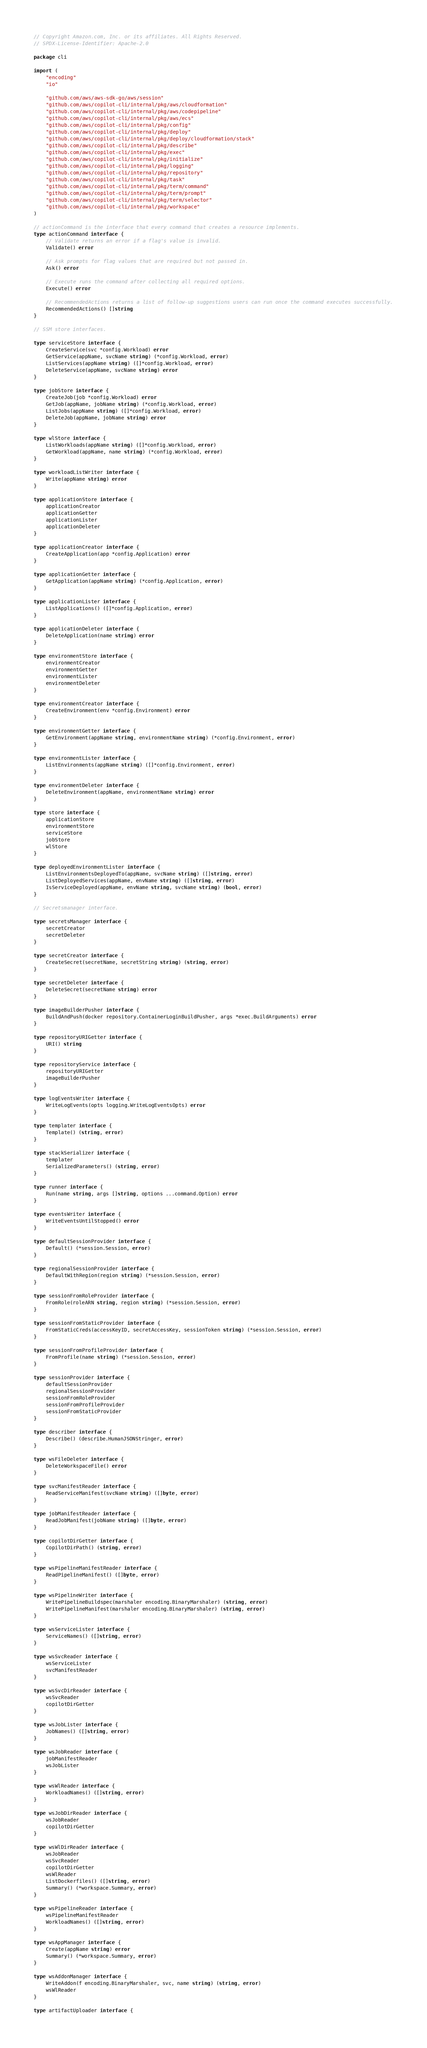<code> <loc_0><loc_0><loc_500><loc_500><_Go_>// Copyright Amazon.com, Inc. or its affiliates. All Rights Reserved.
// SPDX-License-Identifier: Apache-2.0

package cli

import (
	"encoding"
	"io"

	"github.com/aws/aws-sdk-go/aws/session"
	"github.com/aws/copilot-cli/internal/pkg/aws/cloudformation"
	"github.com/aws/copilot-cli/internal/pkg/aws/codepipeline"
	"github.com/aws/copilot-cli/internal/pkg/aws/ecs"
	"github.com/aws/copilot-cli/internal/pkg/config"
	"github.com/aws/copilot-cli/internal/pkg/deploy"
	"github.com/aws/copilot-cli/internal/pkg/deploy/cloudformation/stack"
	"github.com/aws/copilot-cli/internal/pkg/describe"
	"github.com/aws/copilot-cli/internal/pkg/exec"
	"github.com/aws/copilot-cli/internal/pkg/initialize"
	"github.com/aws/copilot-cli/internal/pkg/logging"
	"github.com/aws/copilot-cli/internal/pkg/repository"
	"github.com/aws/copilot-cli/internal/pkg/task"
	"github.com/aws/copilot-cli/internal/pkg/term/command"
	"github.com/aws/copilot-cli/internal/pkg/term/prompt"
	"github.com/aws/copilot-cli/internal/pkg/term/selector"
	"github.com/aws/copilot-cli/internal/pkg/workspace"
)

// actionCommand is the interface that every command that creates a resource implements.
type actionCommand interface {
	// Validate returns an error if a flag's value is invalid.
	Validate() error

	// Ask prompts for flag values that are required but not passed in.
	Ask() error

	// Execute runs the command after collecting all required options.
	Execute() error

	// RecommendedActions returns a list of follow-up suggestions users can run once the command executes successfully.
	RecommendedActions() []string
}

// SSM store interfaces.

type serviceStore interface {
	CreateService(svc *config.Workload) error
	GetService(appName, svcName string) (*config.Workload, error)
	ListServices(appName string) ([]*config.Workload, error)
	DeleteService(appName, svcName string) error
}

type jobStore interface {
	CreateJob(job *config.Workload) error
	GetJob(appName, jobName string) (*config.Workload, error)
	ListJobs(appName string) ([]*config.Workload, error)
	DeleteJob(appName, jobName string) error
}

type wlStore interface {
	ListWorkloads(appName string) ([]*config.Workload, error)
	GetWorkload(appName, name string) (*config.Workload, error)
}

type workloadListWriter interface {
	Write(appName string) error
}

type applicationStore interface {
	applicationCreator
	applicationGetter
	applicationLister
	applicationDeleter
}

type applicationCreator interface {
	CreateApplication(app *config.Application) error
}

type applicationGetter interface {
	GetApplication(appName string) (*config.Application, error)
}

type applicationLister interface {
	ListApplications() ([]*config.Application, error)
}

type applicationDeleter interface {
	DeleteApplication(name string) error
}

type environmentStore interface {
	environmentCreator
	environmentGetter
	environmentLister
	environmentDeleter
}

type environmentCreator interface {
	CreateEnvironment(env *config.Environment) error
}

type environmentGetter interface {
	GetEnvironment(appName string, environmentName string) (*config.Environment, error)
}

type environmentLister interface {
	ListEnvironments(appName string) ([]*config.Environment, error)
}

type environmentDeleter interface {
	DeleteEnvironment(appName, environmentName string) error
}

type store interface {
	applicationStore
	environmentStore
	serviceStore
	jobStore
	wlStore
}

type deployedEnvironmentLister interface {
	ListEnvironmentsDeployedTo(appName, svcName string) ([]string, error)
	ListDeployedServices(appName, envName string) ([]string, error)
	IsServiceDeployed(appName, envName string, svcName string) (bool, error)
}

// Secretsmanager interface.

type secretsManager interface {
	secretCreator
	secretDeleter
}

type secretCreator interface {
	CreateSecret(secretName, secretString string) (string, error)
}

type secretDeleter interface {
	DeleteSecret(secretName string) error
}

type imageBuilderPusher interface {
	BuildAndPush(docker repository.ContainerLoginBuildPusher, args *exec.BuildArguments) error
}

type repositoryURIGetter interface {
	URI() string
}

type repositoryService interface {
	repositoryURIGetter
	imageBuilderPusher
}

type logEventsWriter interface {
	WriteLogEvents(opts logging.WriteLogEventsOpts) error
}

type templater interface {
	Template() (string, error)
}

type stackSerializer interface {
	templater
	SerializedParameters() (string, error)
}

type runner interface {
	Run(name string, args []string, options ...command.Option) error
}

type eventsWriter interface {
	WriteEventsUntilStopped() error
}

type defaultSessionProvider interface {
	Default() (*session.Session, error)
}

type regionalSessionProvider interface {
	DefaultWithRegion(region string) (*session.Session, error)
}

type sessionFromRoleProvider interface {
	FromRole(roleARN string, region string) (*session.Session, error)
}

type sessionFromStaticProvider interface {
	FromStaticCreds(accessKeyID, secretAccessKey, sessionToken string) (*session.Session, error)
}

type sessionFromProfileProvider interface {
	FromProfile(name string) (*session.Session, error)
}

type sessionProvider interface {
	defaultSessionProvider
	regionalSessionProvider
	sessionFromRoleProvider
	sessionFromProfileProvider
	sessionFromStaticProvider
}

type describer interface {
	Describe() (describe.HumanJSONStringer, error)
}

type wsFileDeleter interface {
	DeleteWorkspaceFile() error
}

type svcManifestReader interface {
	ReadServiceManifest(svcName string) ([]byte, error)
}

type jobManifestReader interface {
	ReadJobManifest(jobName string) ([]byte, error)
}

type copilotDirGetter interface {
	CopilotDirPath() (string, error)
}

type wsPipelineManifestReader interface {
	ReadPipelineManifest() ([]byte, error)
}

type wsPipelineWriter interface {
	WritePipelineBuildspec(marshaler encoding.BinaryMarshaler) (string, error)
	WritePipelineManifest(marshaler encoding.BinaryMarshaler) (string, error)
}

type wsServiceLister interface {
	ServiceNames() ([]string, error)
}

type wsSvcReader interface {
	wsServiceLister
	svcManifestReader
}

type wsSvcDirReader interface {
	wsSvcReader
	copilotDirGetter
}

type wsJobLister interface {
	JobNames() ([]string, error)
}

type wsJobReader interface {
	jobManifestReader
	wsJobLister
}

type wsWlReader interface {
	WorkloadNames() ([]string, error)
}

type wsJobDirReader interface {
	wsJobReader
	copilotDirGetter
}

type wsWlDirReader interface {
	wsJobReader
	wsSvcReader
	copilotDirGetter
	wsWlReader
	ListDockerfiles() ([]string, error)
	Summary() (*workspace.Summary, error)
}

type wsPipelineReader interface {
	wsPipelineManifestReader
	WorkloadNames() ([]string, error)
}

type wsAppManager interface {
	Create(appName string) error
	Summary() (*workspace.Summary, error)
}

type wsAddonManager interface {
	WriteAddon(f encoding.BinaryMarshaler, svc, name string) (string, error)
	wsWlReader
}

type artifactUploader interface {</code> 